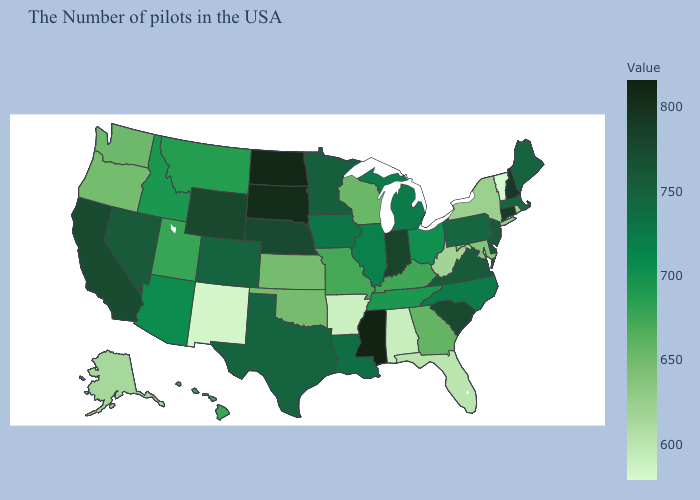Does Georgia have a lower value than New Hampshire?
Write a very short answer. Yes. Which states have the lowest value in the Northeast?
Write a very short answer. Vermont. Among the states that border Illinois , does Missouri have the lowest value?
Write a very short answer. No. Which states hav the highest value in the West?
Write a very short answer. Wyoming. Does the map have missing data?
Answer briefly. No. Does Kansas have a lower value than Wyoming?
Concise answer only. Yes. Does Vermont have the lowest value in the USA?
Keep it brief. Yes. 